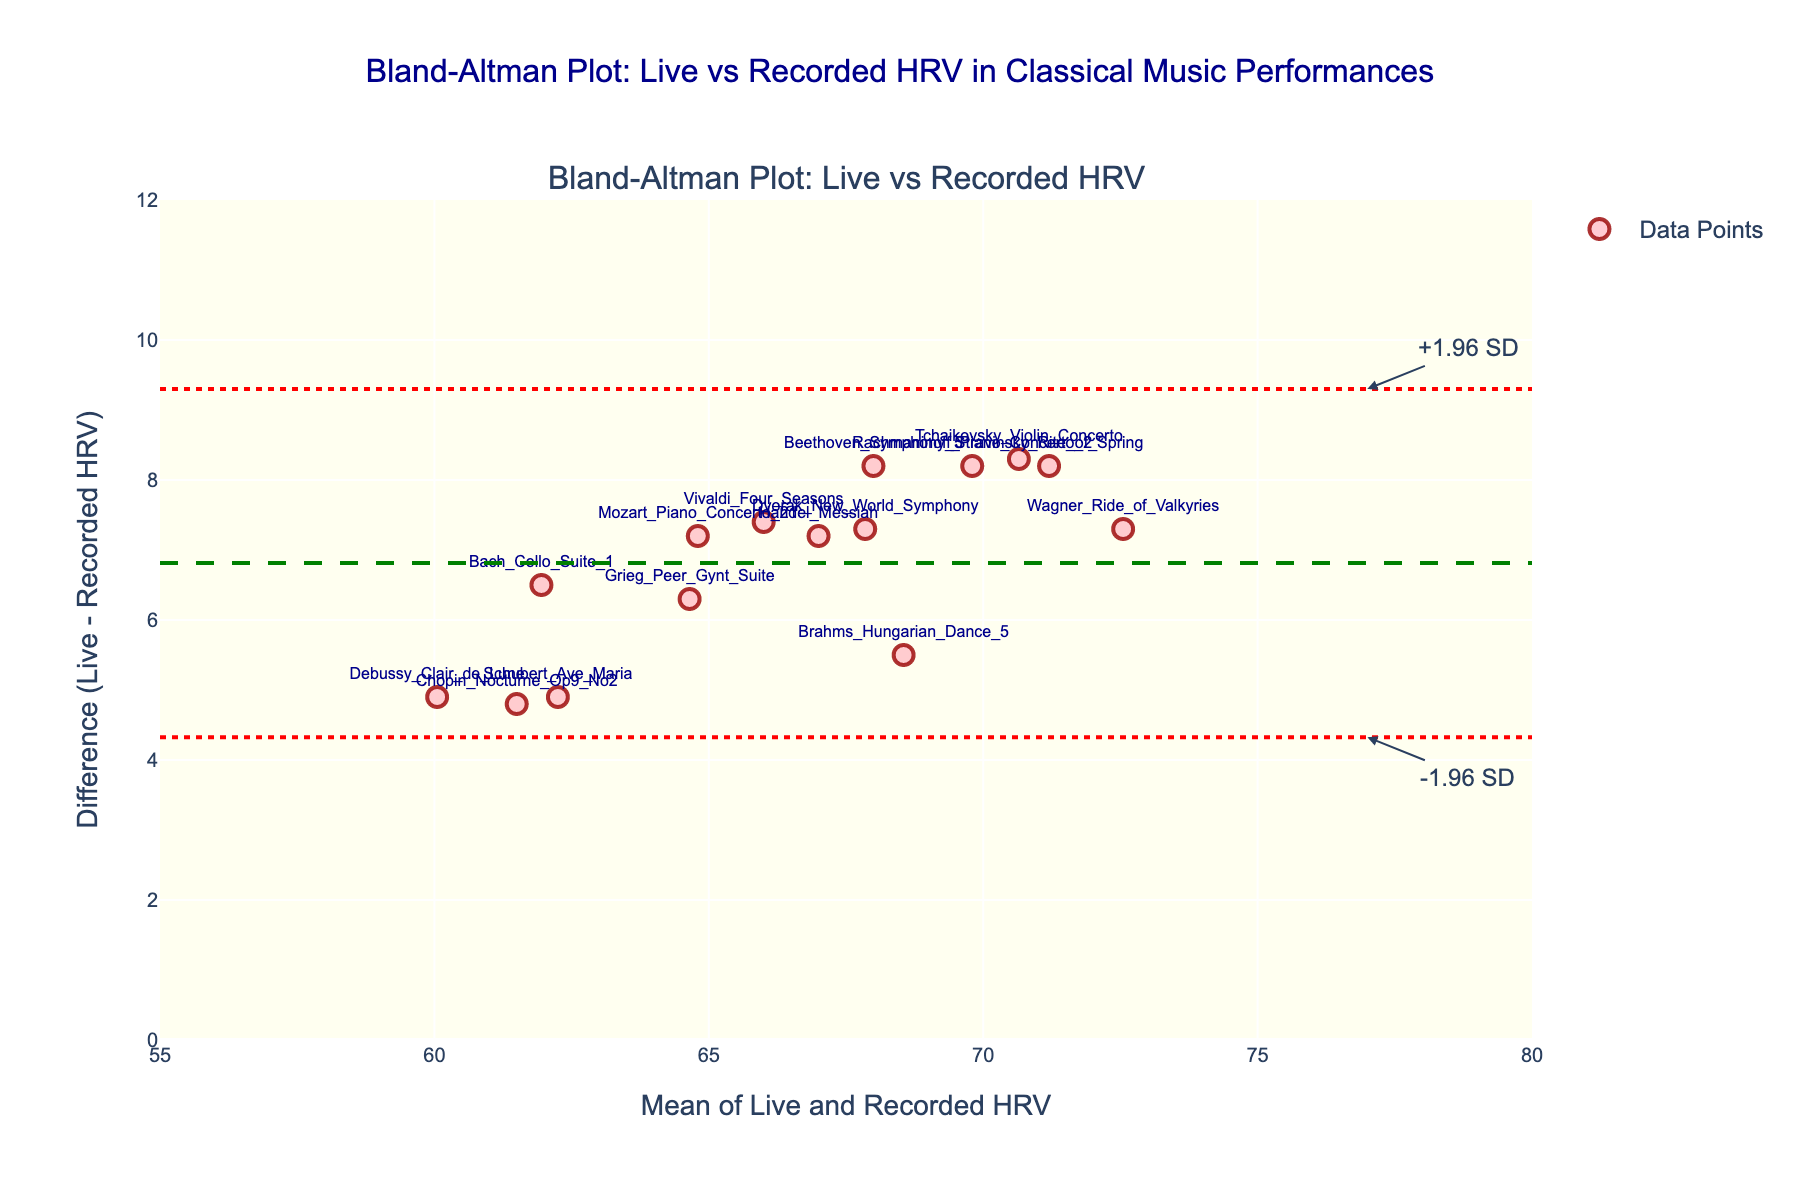What's the title of the figure? Look at the top of the figure where the title is prominently displayed.
Answer: Bland-Altman Plot: Live vs Recorded HRV in Classical Music Performances What's the x-axis label in the plot? The x-axis label is usually mentioned alongside the horizontal axis.
Answer: Mean of Live and Recorded HRV What's the y-axis label in the plot? The y-axis label is usually mentioned alongside the vertical axis.
Answer: Difference (Live - Recorded HRV) How many data points are shown in the plot? Count the number of markers (data points) displayed in the plot.
Answer: 15 What color are the data points? Observe the color used for the markers representing the data points.
Answer: Light pink What's the mean difference of HRV between live and recorded performances? Locate the horizontal dashed green line, which represents the mean difference.
Answer: Approximately 6.9 What are the upper and lower limits of agreement? Find the horizontal dotted red lines which mark the limits of agreement, typically calculated as mean difference ± 1.96 standard deviations.
Answer: Approximately 4.4 and 9.5 Which performance has the highest difference in HRV? Identify the highest data point on the y-axis, and refer to its label.
Answer: Tchaikovsky_Violin_Concerto Which performances have the exact same difference in HRV? Look for markers that align horizontally at the same difference value and have identical y-coordinates.
Answer: Beethoven_Symphony_5, Stravinsky_Rite_of_Spring, and Rachmaninoff_Piano_Concerto_2 Is there a noticeable bias in HRV between live and recorded performances? Check the position of most data points relative to the mean difference line. Since they are generally above, HRV during live performances tends to be higher than recorded.
Answer: Yes, live performances tend to have higher HRV 